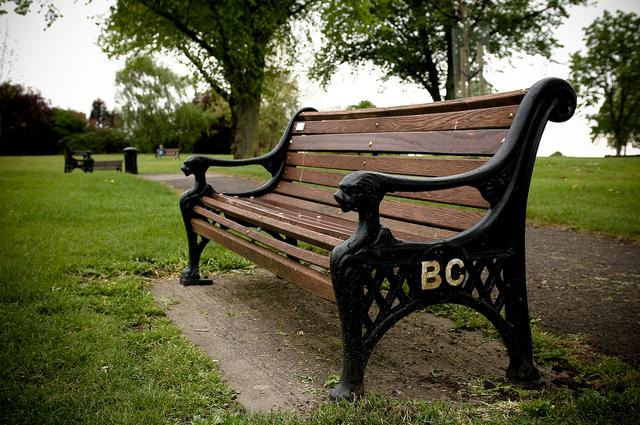What type of bench is this?

Choices:
A) blue
B) park
C) bus
D) chair park 